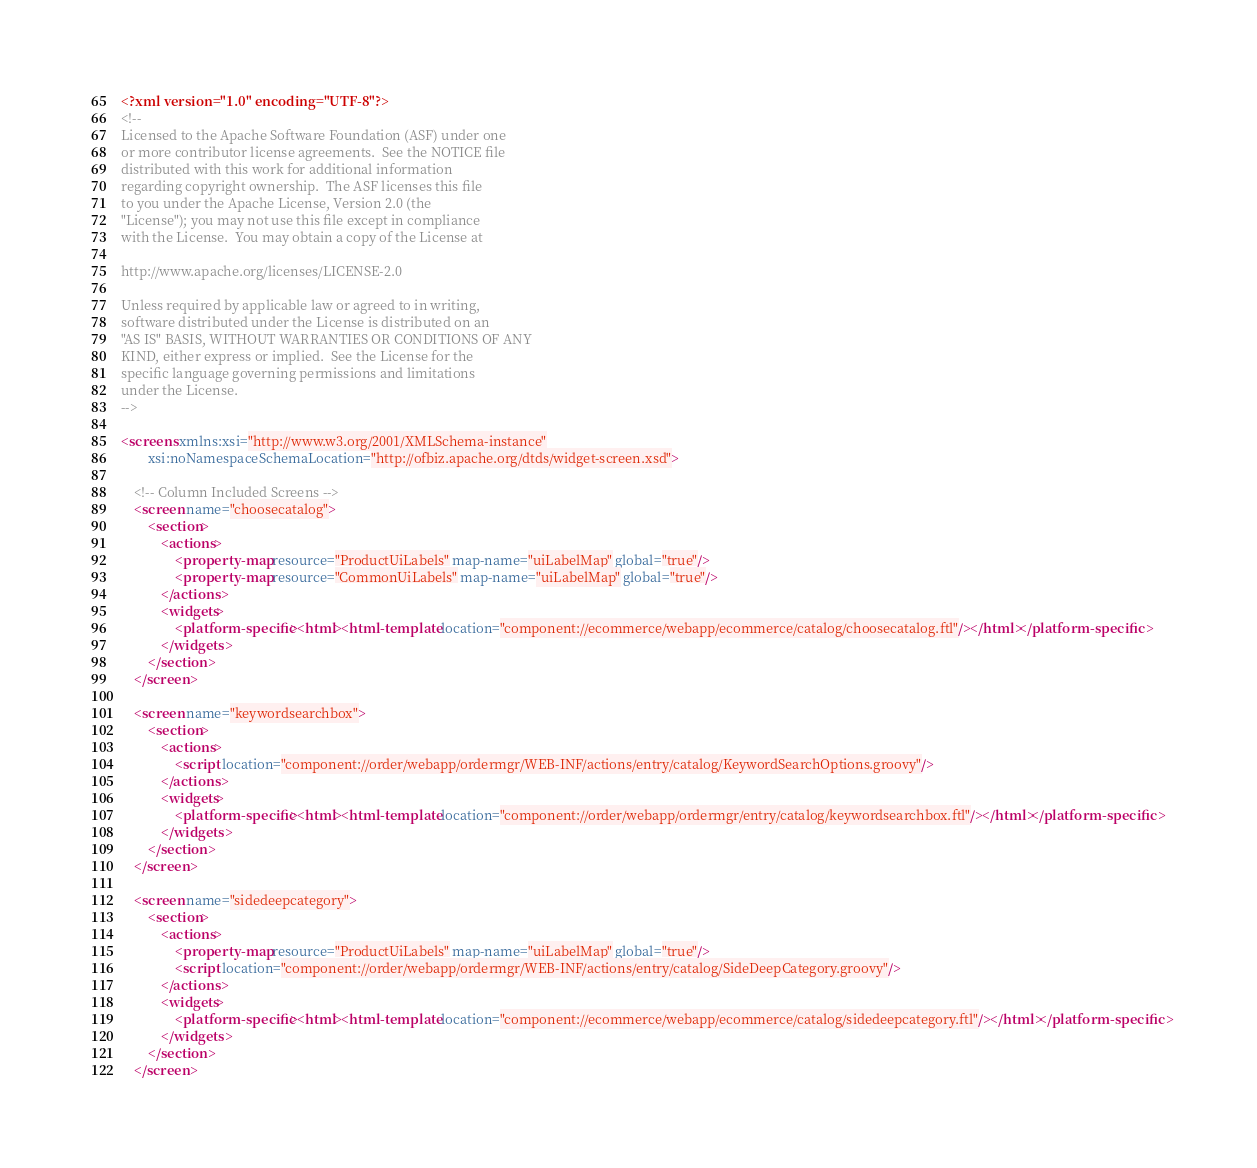Convert code to text. <code><loc_0><loc_0><loc_500><loc_500><_XML_><?xml version="1.0" encoding="UTF-8"?>
<!--
Licensed to the Apache Software Foundation (ASF) under one
or more contributor license agreements.  See the NOTICE file
distributed with this work for additional information
regarding copyright ownership.  The ASF licenses this file
to you under the Apache License, Version 2.0 (the
"License"); you may not use this file except in compliance
with the License.  You may obtain a copy of the License at

http://www.apache.org/licenses/LICENSE-2.0

Unless required by applicable law or agreed to in writing,
software distributed under the License is distributed on an
"AS IS" BASIS, WITHOUT WARRANTIES OR CONDITIONS OF ANY
KIND, either express or implied.  See the License for the
specific language governing permissions and limitations
under the License.
-->

<screens xmlns:xsi="http://www.w3.org/2001/XMLSchema-instance"
        xsi:noNamespaceSchemaLocation="http://ofbiz.apache.org/dtds/widget-screen.xsd">

    <!-- Column Included Screens -->
    <screen name="choosecatalog">
        <section>
            <actions>
                <property-map resource="ProductUiLabels" map-name="uiLabelMap" global="true"/>
                <property-map resource="CommonUiLabels" map-name="uiLabelMap" global="true"/>
            </actions>
            <widgets>
                <platform-specific><html><html-template location="component://ecommerce/webapp/ecommerce/catalog/choosecatalog.ftl"/></html></platform-specific>
            </widgets>
        </section>
    </screen>

    <screen name="keywordsearchbox">
        <section>
            <actions>
                <script location="component://order/webapp/ordermgr/WEB-INF/actions/entry/catalog/KeywordSearchOptions.groovy"/>
            </actions>
            <widgets>
                <platform-specific><html><html-template location="component://order/webapp/ordermgr/entry/catalog/keywordsearchbox.ftl"/></html></platform-specific>
            </widgets>
        </section>
    </screen>

    <screen name="sidedeepcategory">
        <section>
            <actions>
                <property-map resource="ProductUiLabels" map-name="uiLabelMap" global="true"/>
                <script location="component://order/webapp/ordermgr/WEB-INF/actions/entry/catalog/SideDeepCategory.groovy"/>
            </actions>
            <widgets>
                <platform-specific><html><html-template location="component://ecommerce/webapp/ecommerce/catalog/sidedeepcategory.ftl"/></html></platform-specific>
            </widgets>
        </section>
    </screen>
</code> 